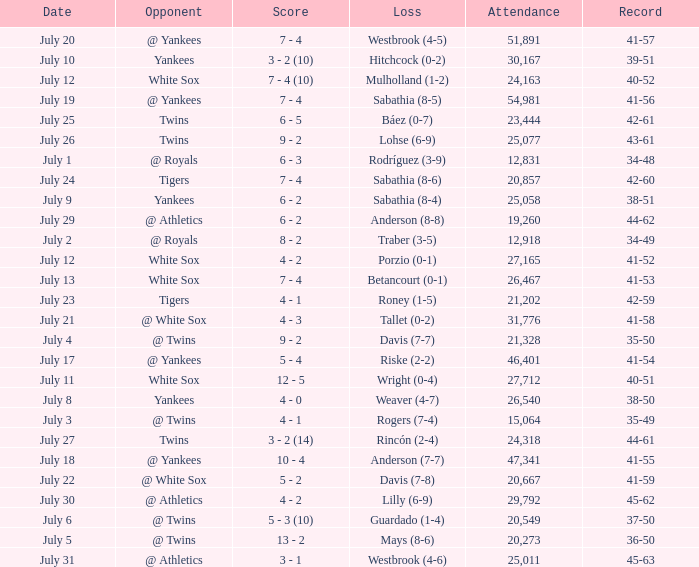Which Record has an Opponent of twins, and a Date of july 25? 42-61. 